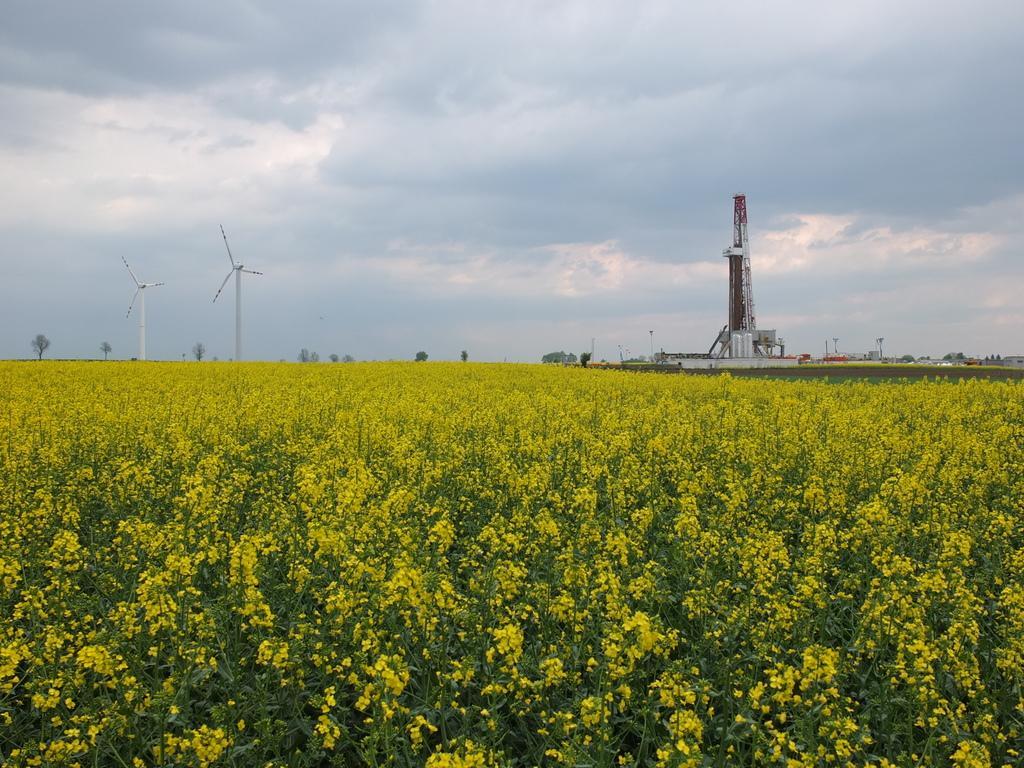Can you describe this image briefly? In the picture we can see, full of plants with yellow color flowers to it and far away from it, we can see a factory and besides, we can see two windmills and far away from it we can see some trees and in the background we can see a sky and clouds. 